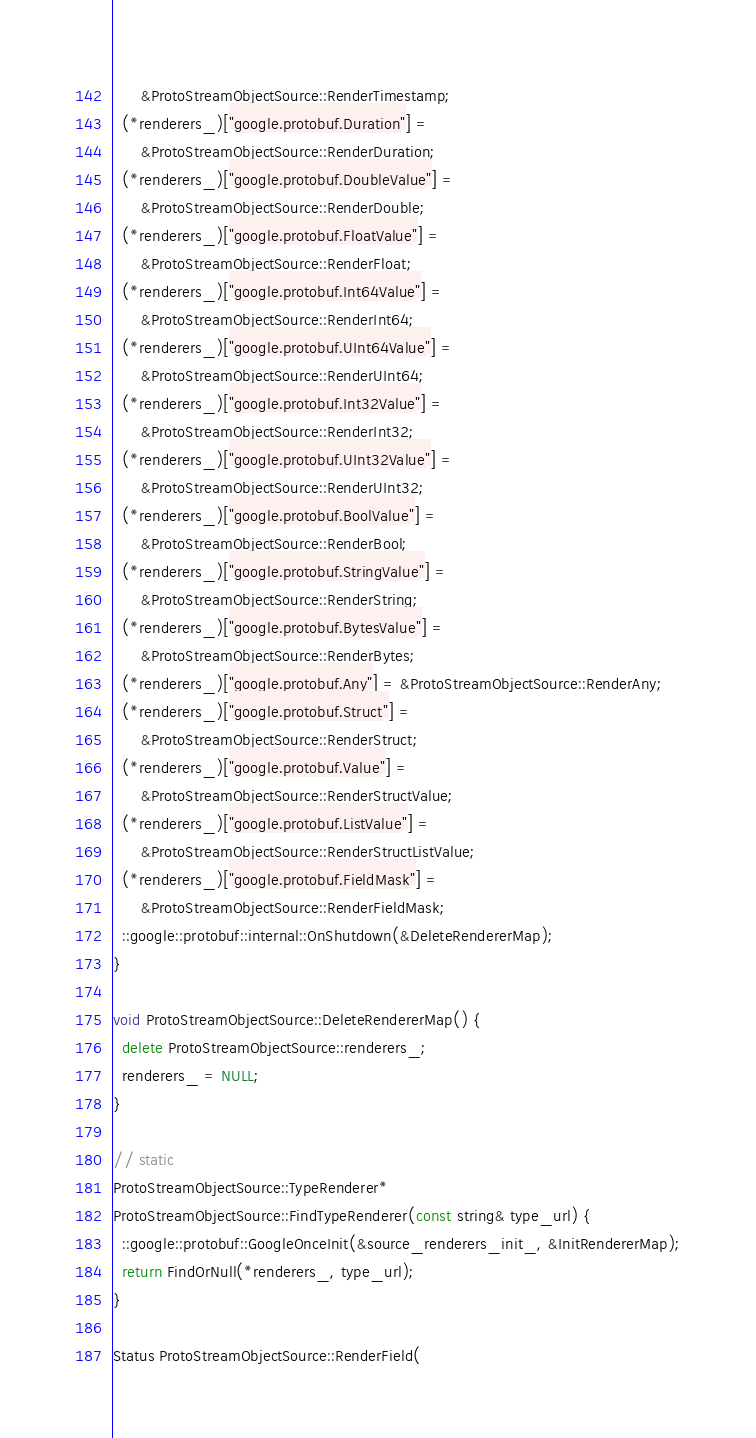Convert code to text. <code><loc_0><loc_0><loc_500><loc_500><_C++_>      &ProtoStreamObjectSource::RenderTimestamp;
  (*renderers_)["google.protobuf.Duration"] =
      &ProtoStreamObjectSource::RenderDuration;
  (*renderers_)["google.protobuf.DoubleValue"] =
      &ProtoStreamObjectSource::RenderDouble;
  (*renderers_)["google.protobuf.FloatValue"] =
      &ProtoStreamObjectSource::RenderFloat;
  (*renderers_)["google.protobuf.Int64Value"] =
      &ProtoStreamObjectSource::RenderInt64;
  (*renderers_)["google.protobuf.UInt64Value"] =
      &ProtoStreamObjectSource::RenderUInt64;
  (*renderers_)["google.protobuf.Int32Value"] =
      &ProtoStreamObjectSource::RenderInt32;
  (*renderers_)["google.protobuf.UInt32Value"] =
      &ProtoStreamObjectSource::RenderUInt32;
  (*renderers_)["google.protobuf.BoolValue"] =
      &ProtoStreamObjectSource::RenderBool;
  (*renderers_)["google.protobuf.StringValue"] =
      &ProtoStreamObjectSource::RenderString;
  (*renderers_)["google.protobuf.BytesValue"] =
      &ProtoStreamObjectSource::RenderBytes;
  (*renderers_)["google.protobuf.Any"] = &ProtoStreamObjectSource::RenderAny;
  (*renderers_)["google.protobuf.Struct"] =
      &ProtoStreamObjectSource::RenderStruct;
  (*renderers_)["google.protobuf.Value"] =
      &ProtoStreamObjectSource::RenderStructValue;
  (*renderers_)["google.protobuf.ListValue"] =
      &ProtoStreamObjectSource::RenderStructListValue;
  (*renderers_)["google.protobuf.FieldMask"] =
      &ProtoStreamObjectSource::RenderFieldMask;
  ::google::protobuf::internal::OnShutdown(&DeleteRendererMap);
}

void ProtoStreamObjectSource::DeleteRendererMap() {
  delete ProtoStreamObjectSource::renderers_;
  renderers_ = NULL;
}

// static
ProtoStreamObjectSource::TypeRenderer*
ProtoStreamObjectSource::FindTypeRenderer(const string& type_url) {
  ::google::protobuf::GoogleOnceInit(&source_renderers_init_, &InitRendererMap);
  return FindOrNull(*renderers_, type_url);
}

Status ProtoStreamObjectSource::RenderField(</code> 